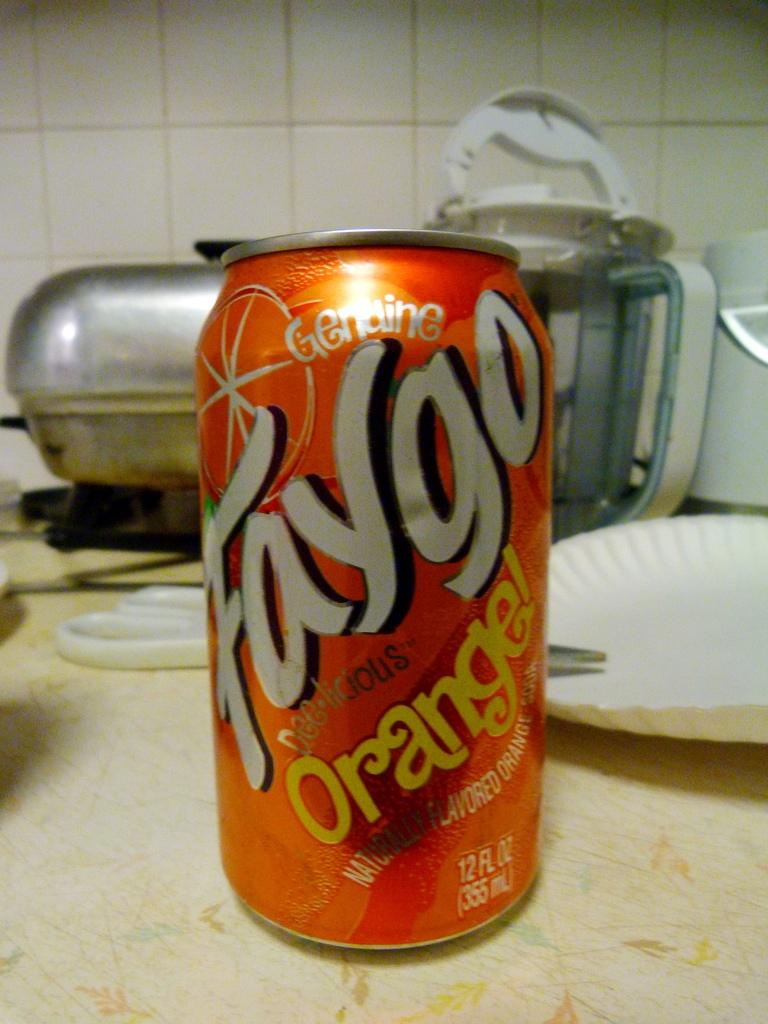<image>
Offer a succinct explanation of the picture presented. the word faygo that is on an orange can 